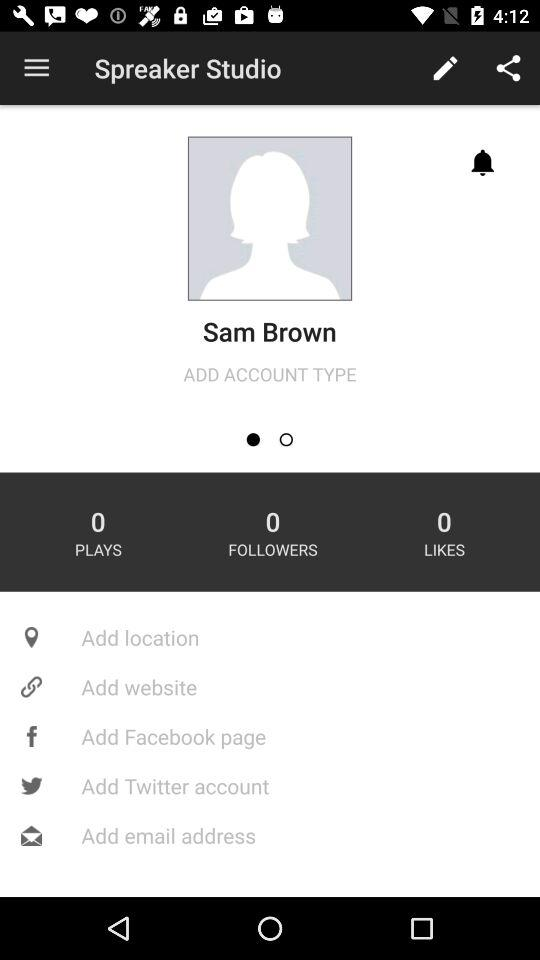How many plays in total are there? There are 0 plays. 